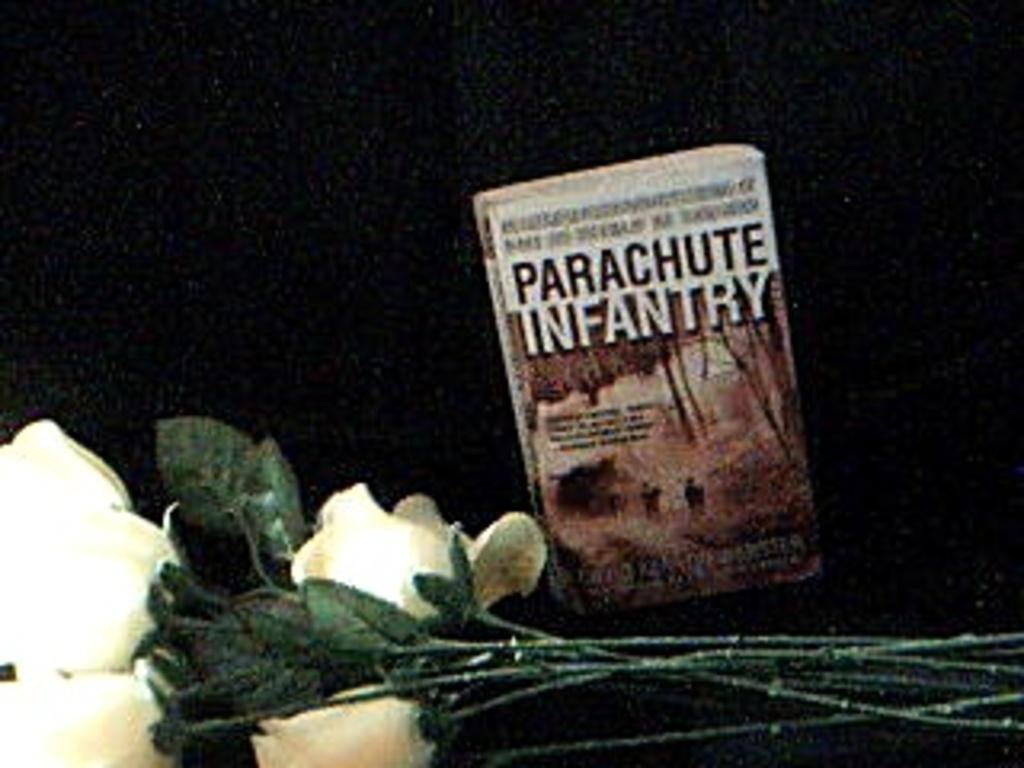What type of plants are visible in the image? There are flowers and leaves in the image. What object can be seen besides the plants? There is a book in the image. What is the color of the background in the image? The background of the image is dark. What type of board can be seen in the image? There is no board present in the image. Is there a train visible in the image? No, there is no train visible in the image. 